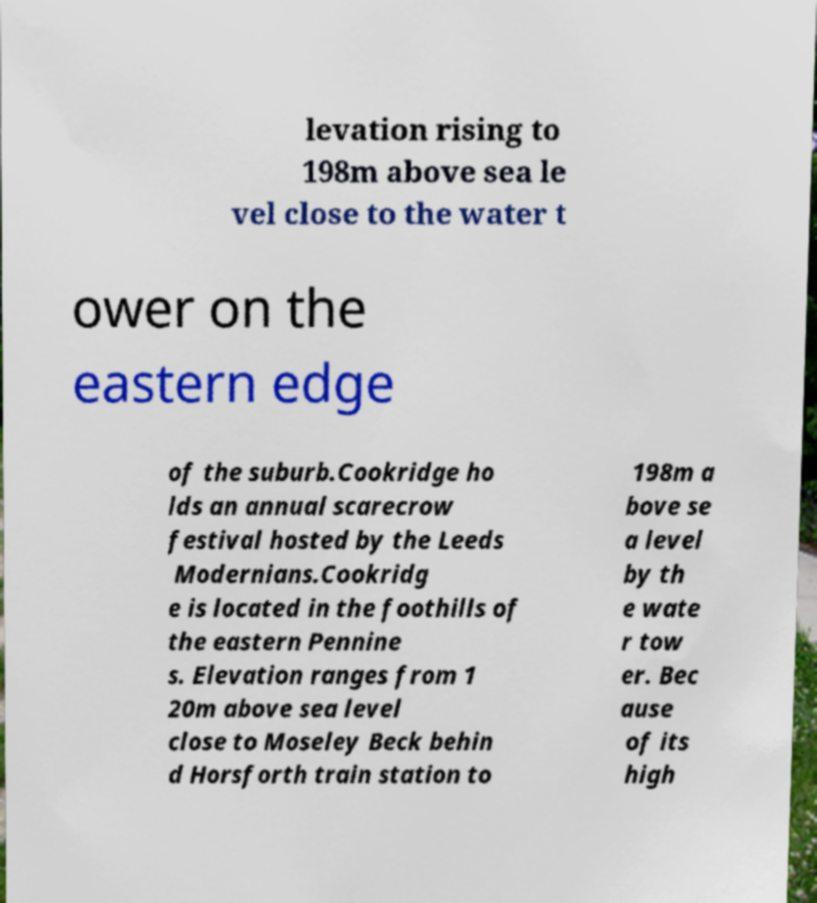What messages or text are displayed in this image? I need them in a readable, typed format. levation rising to 198m above sea le vel close to the water t ower on the eastern edge of the suburb.Cookridge ho lds an annual scarecrow festival hosted by the Leeds Modernians.Cookridg e is located in the foothills of the eastern Pennine s. Elevation ranges from 1 20m above sea level close to Moseley Beck behin d Horsforth train station to 198m a bove se a level by th e wate r tow er. Bec ause of its high 